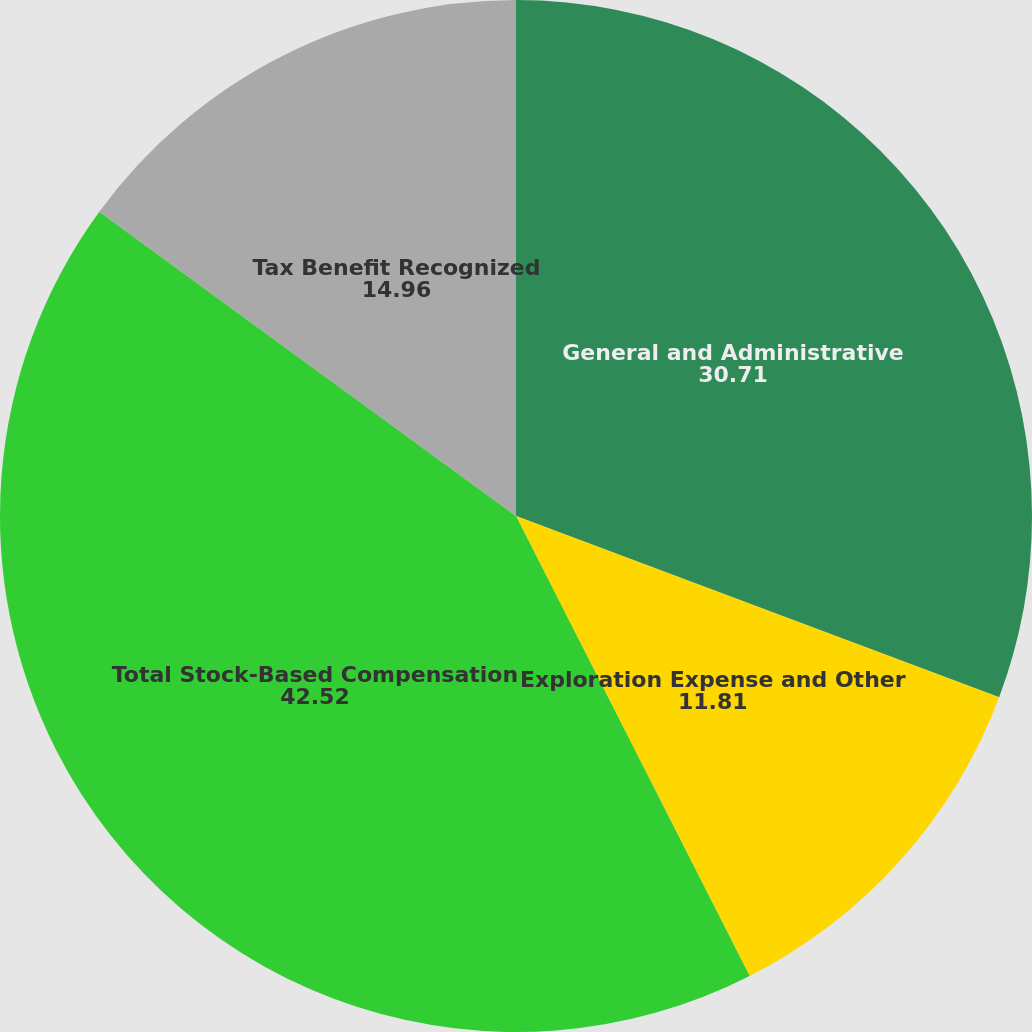Convert chart to OTSL. <chart><loc_0><loc_0><loc_500><loc_500><pie_chart><fcel>General and Administrative<fcel>Exploration Expense and Other<fcel>Total Stock-Based Compensation<fcel>Tax Benefit Recognized<nl><fcel>30.71%<fcel>11.81%<fcel>42.52%<fcel>14.96%<nl></chart> 